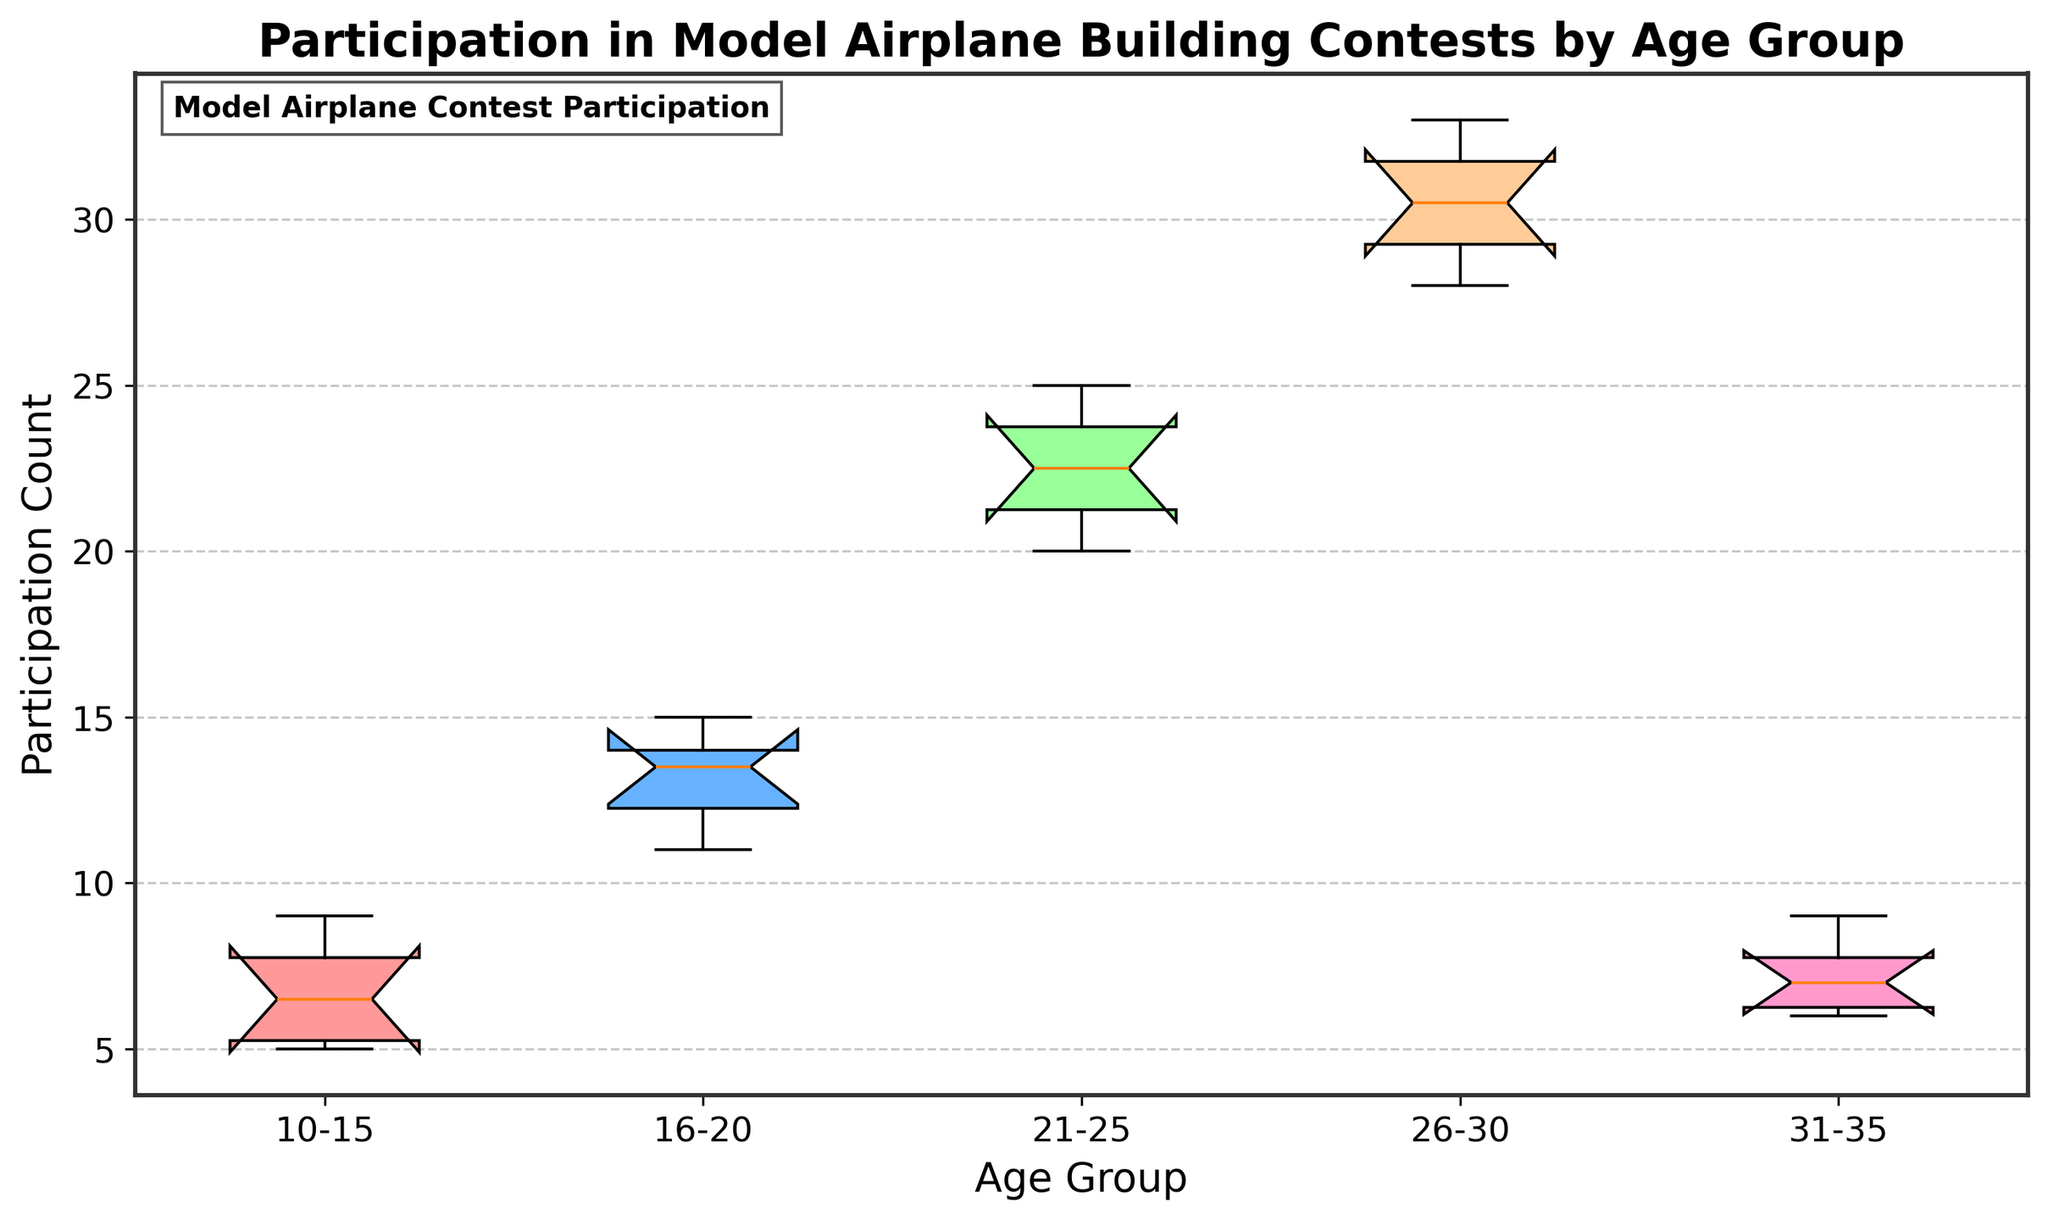What's the title of the plot? The title of the plot is typically displayed at the top of the figure. In this case, it is "Participation in Model Airplane Building Contests by Age Group."
Answer: Participation in Model Airplane Building Contests by Age Group What is the age group with the highest median participation count? The median of each age group can be identified by the central marker inside the notch of each box. The group with the highest median is "26-30."
Answer: 26-30 How many age groups are represented in the plot? Count the number of distinct boxes or labels along the x-axis, representing different age groups. There are five distinct labels visible.
Answer: 5 Which age group has the widest interquartile range (IQR)? The IQR is the width of the box (distance between the first quartile and third quartile). The widest box represents the age group "26-30," indicating it has the widest IQR.
Answer: 26-30 Which age group has the lowest lower whisker value? The lower whisker represents the minimum value within 1.5 times the IQR from the first quartile. By comparing whiskers, "10-15" has the lowest lower whisker value.
Answer: 10-15 What are the upper and lower boundaries of the notch for the "21-25" age group? The notches in the box plot represent the confidence interval around the median. By examining the notches on the "21-25" box, the boundaries can be identified.
Answer: Upper: upper boundary of the median notch for "21-25"; Lower: lower boundary of the median notch for "21-25" Compare the median participation count between age groups "16-20" and "31-35". Which group has a higher median? Compare the central markers within the notches for the two groups. The median for "16-20" is visibly higher than "31-35."
Answer: 16-20 Which age group has the smallest interquartile range (IQR)? The IQR is the width of the box. The smallest box width for IQR is observed in age group "31-35."
Answer: 31-35 Is there an overlap between the notches of the "10-15" and "31-35" age groups? If the notches of the boxes overlap, it indicates the medians are not significantly different. Check the notches of "10-15" and "31-35" for any overlap.
Answer: Yes Identify the range of participation counts for the "21-25" age group. The range is determined by subtracting the lowest value (lower whisker) from the highest value (upper whisker). For "21-25," identify these whisker values and compute the range.
Answer: Range for "21-25": highest value - lowest value 